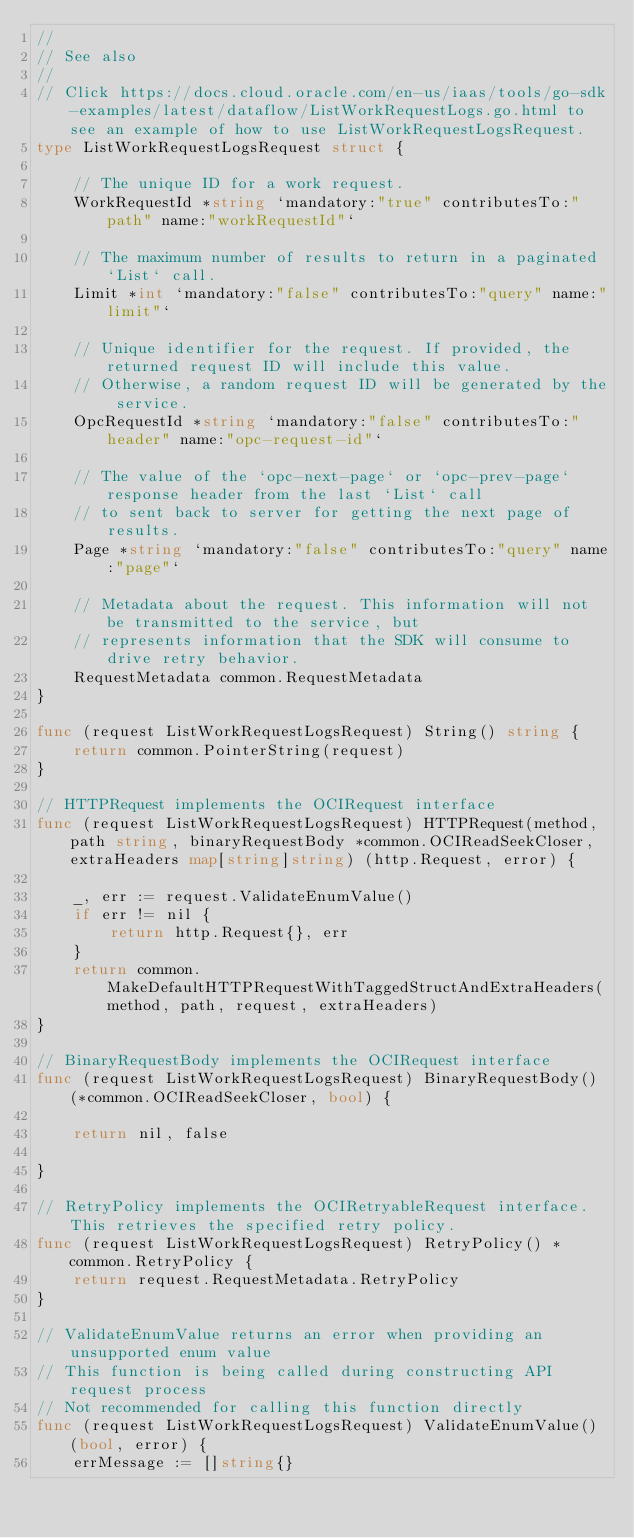<code> <loc_0><loc_0><loc_500><loc_500><_Go_>//
// See also
//
// Click https://docs.cloud.oracle.com/en-us/iaas/tools/go-sdk-examples/latest/dataflow/ListWorkRequestLogs.go.html to see an example of how to use ListWorkRequestLogsRequest.
type ListWorkRequestLogsRequest struct {

	// The unique ID for a work request.
	WorkRequestId *string `mandatory:"true" contributesTo:"path" name:"workRequestId"`

	// The maximum number of results to return in a paginated `List` call.
	Limit *int `mandatory:"false" contributesTo:"query" name:"limit"`

	// Unique identifier for the request. If provided, the returned request ID will include this value.
	// Otherwise, a random request ID will be generated by the service.
	OpcRequestId *string `mandatory:"false" contributesTo:"header" name:"opc-request-id"`

	// The value of the `opc-next-page` or `opc-prev-page` response header from the last `List` call
	// to sent back to server for getting the next page of results.
	Page *string `mandatory:"false" contributesTo:"query" name:"page"`

	// Metadata about the request. This information will not be transmitted to the service, but
	// represents information that the SDK will consume to drive retry behavior.
	RequestMetadata common.RequestMetadata
}

func (request ListWorkRequestLogsRequest) String() string {
	return common.PointerString(request)
}

// HTTPRequest implements the OCIRequest interface
func (request ListWorkRequestLogsRequest) HTTPRequest(method, path string, binaryRequestBody *common.OCIReadSeekCloser, extraHeaders map[string]string) (http.Request, error) {

	_, err := request.ValidateEnumValue()
	if err != nil {
		return http.Request{}, err
	}
	return common.MakeDefaultHTTPRequestWithTaggedStructAndExtraHeaders(method, path, request, extraHeaders)
}

// BinaryRequestBody implements the OCIRequest interface
func (request ListWorkRequestLogsRequest) BinaryRequestBody() (*common.OCIReadSeekCloser, bool) {

	return nil, false

}

// RetryPolicy implements the OCIRetryableRequest interface. This retrieves the specified retry policy.
func (request ListWorkRequestLogsRequest) RetryPolicy() *common.RetryPolicy {
	return request.RequestMetadata.RetryPolicy
}

// ValidateEnumValue returns an error when providing an unsupported enum value
// This function is being called during constructing API request process
// Not recommended for calling this function directly
func (request ListWorkRequestLogsRequest) ValidateEnumValue() (bool, error) {
	errMessage := []string{}</code> 